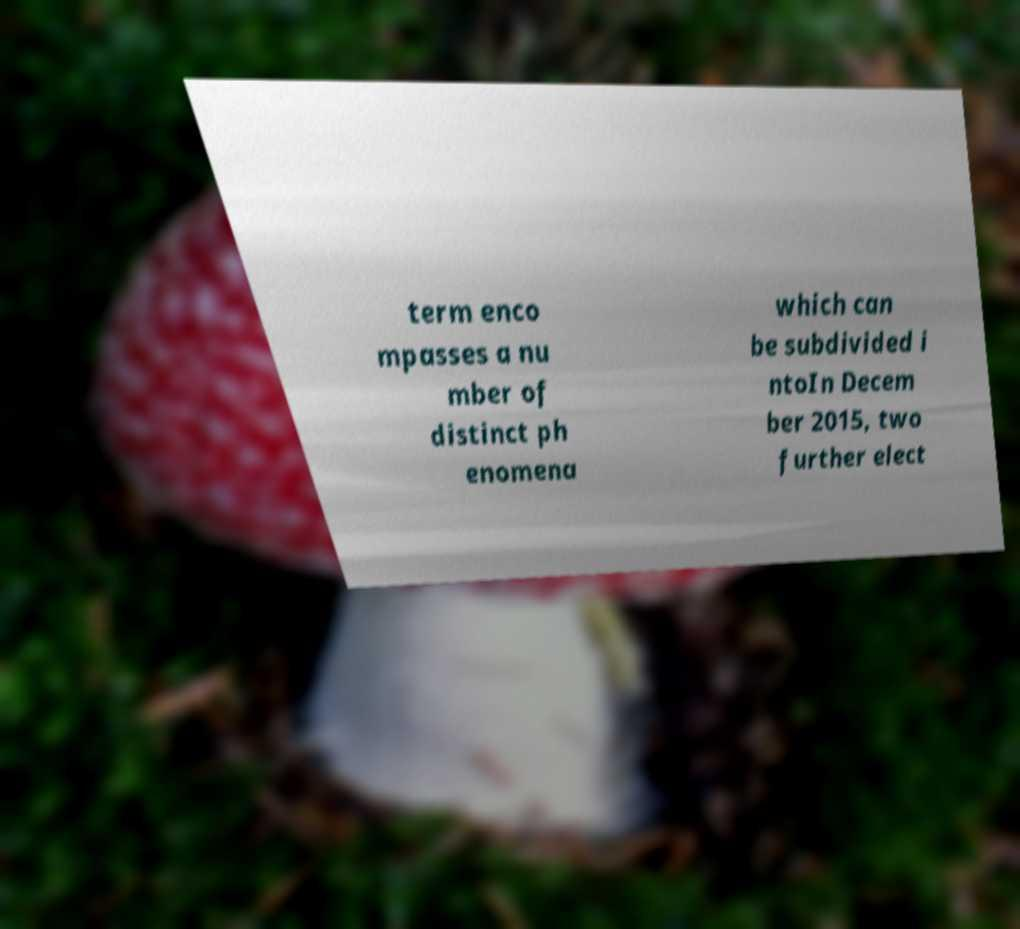Can you accurately transcribe the text from the provided image for me? term enco mpasses a nu mber of distinct ph enomena which can be subdivided i ntoIn Decem ber 2015, two further elect 